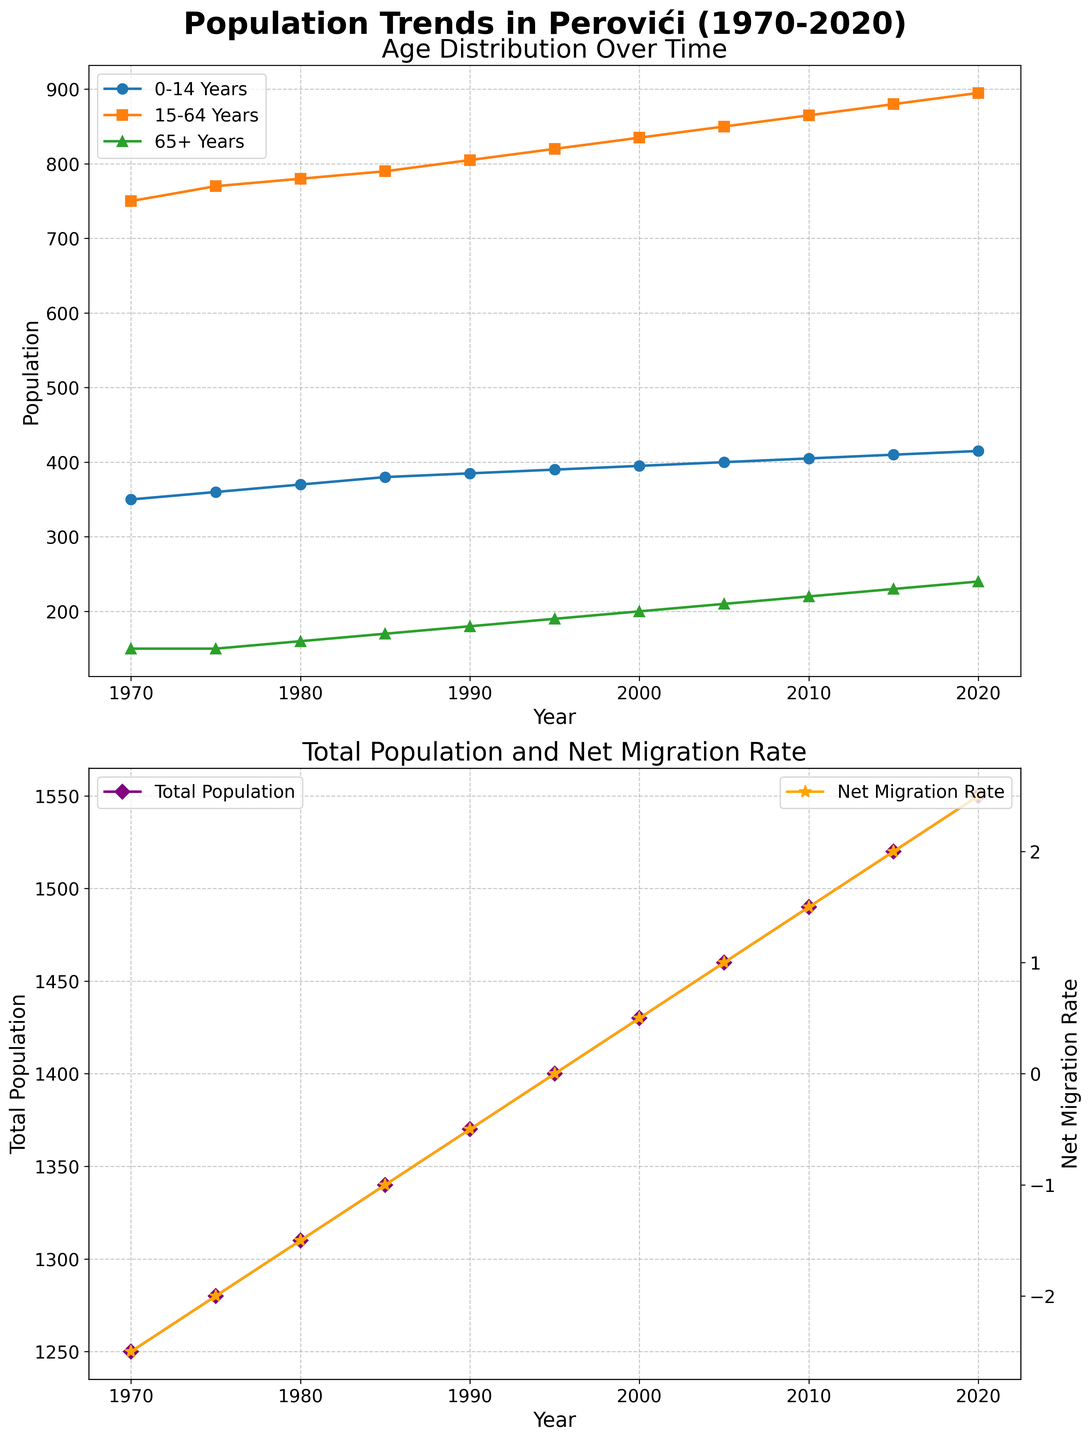What is the total population in Perovići in 1995? Referring to the second subplot of the figure, the total population for the year 1995 is noted on the Total Population line graph.
Answer: 1400 From 1970 to 2020, during which years did the Net Migration Rate go positive? Looking at the second subplot where the Net Migration Rate line is plotted, we can see that the Net Migration Rate became positive starting from 2000 and continued to stay positive onward.
Answer: 2000-2020 What is the sum of the population of people aged 65+ years in 1970 and 2020? From the first subplot, the population for people aged 65+ years in 1970 is 150, and in 2020 is 240. Adding these values: 150 + 240.
Answer: 390 How did the Total Population and Net Migration Rate correlate in terms of trend direction between 1970 and 2020? Observing both lines in the second subplot, as the Net Migration Rate increased from -2.5 to 2.5, the Total Population also gradually increased, indicating a direct correlation.
Answer: Direct correlation Between the age groups 15-64 years and 0-14 years, which group saw a larger increase in population from 1970 to 2020? From the first subplot, the population for the 15-64 years age group increased from 750 to 895, while the 0-14 years group increased from 350 to 415. The increase for 15-64 years is 145, and for 0-14 years, it is 65, which shows a larger increase in the 15-64 years group.
Answer: 15-64 years What age group remained steady in population from 1970 to 1975? Referring to the first subplot, the line for people aged 65+ years did not show any increase, remaining at 150 between 1970 and 1975.
Answer: 65+ years What color represents the Total Population and Net Migration Rate in the second subplot? Examining the colors in the second subplot, Total Population is represented by a purple line, and Net Migration Rate is represented by an orange line.
Answer: Purple, Orange Which age group in the first subplot has the highest population in the year 2020? Observing the first subplot, in 2020, the age group 15-64 years has the highest population with 895 individuals, compared to the other age groups.
Answer: 15-64 years Between which years did the population of people aged 0-14 years show the smallest increase? Looking at the first subplot, the smallest increase in the population of people aged 0-14 years was between 1990 (385) and 1995 (390), with only an increase of 5.
Answer: 1990-1995 What's the difference in population for the 15-64 years age group between 1980 and 2010? Referring to the first subplot, the population for the age group 15-64 years in 1980 was 780, and in 2010 was 865. The difference is 865 - 780.
Answer: 85 